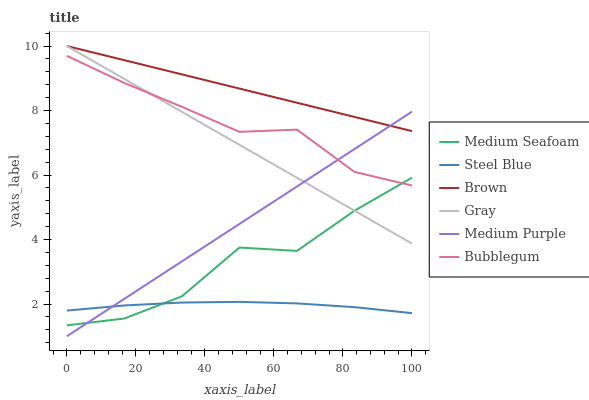Does Steel Blue have the minimum area under the curve?
Answer yes or no. Yes. Does Brown have the maximum area under the curve?
Answer yes or no. Yes. Does Gray have the minimum area under the curve?
Answer yes or no. No. Does Gray have the maximum area under the curve?
Answer yes or no. No. Is Medium Purple the smoothest?
Answer yes or no. Yes. Is Medium Seafoam the roughest?
Answer yes or no. Yes. Is Gray the smoothest?
Answer yes or no. No. Is Gray the roughest?
Answer yes or no. No. Does Medium Purple have the lowest value?
Answer yes or no. Yes. Does Gray have the lowest value?
Answer yes or no. No. Does Gray have the highest value?
Answer yes or no. Yes. Does Steel Blue have the highest value?
Answer yes or no. No. Is Medium Seafoam less than Brown?
Answer yes or no. Yes. Is Brown greater than Bubblegum?
Answer yes or no. Yes. Does Bubblegum intersect Medium Seafoam?
Answer yes or no. Yes. Is Bubblegum less than Medium Seafoam?
Answer yes or no. No. Is Bubblegum greater than Medium Seafoam?
Answer yes or no. No. Does Medium Seafoam intersect Brown?
Answer yes or no. No. 